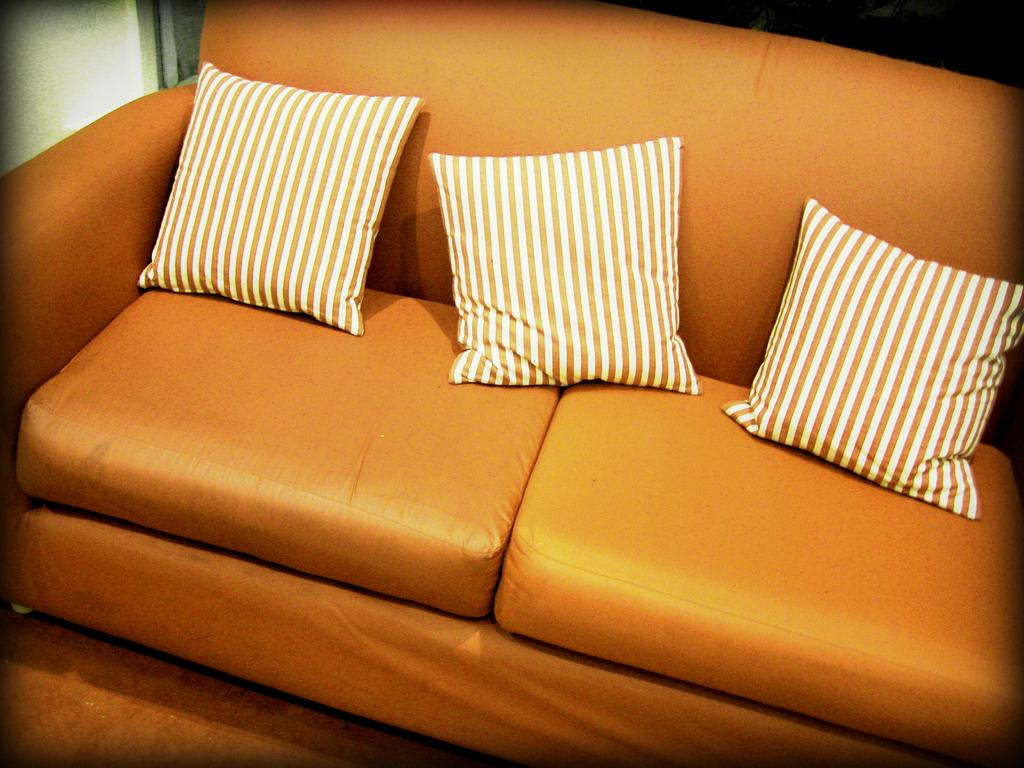What type of furniture is present in the image? There is a sofa in the image. What color is the sofa? The sofa is orange in color. How many pillows are on the sofa? There are three pillows on the sofa. What type of sail can be seen on the sofa in the image? There is no sail present on the sofa in the image. 